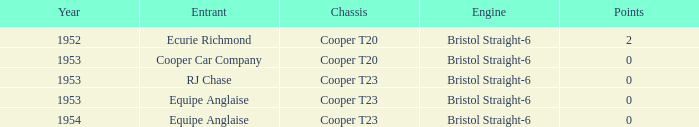Which of the greatest scores had a year more recent than 1953? 0.0. 